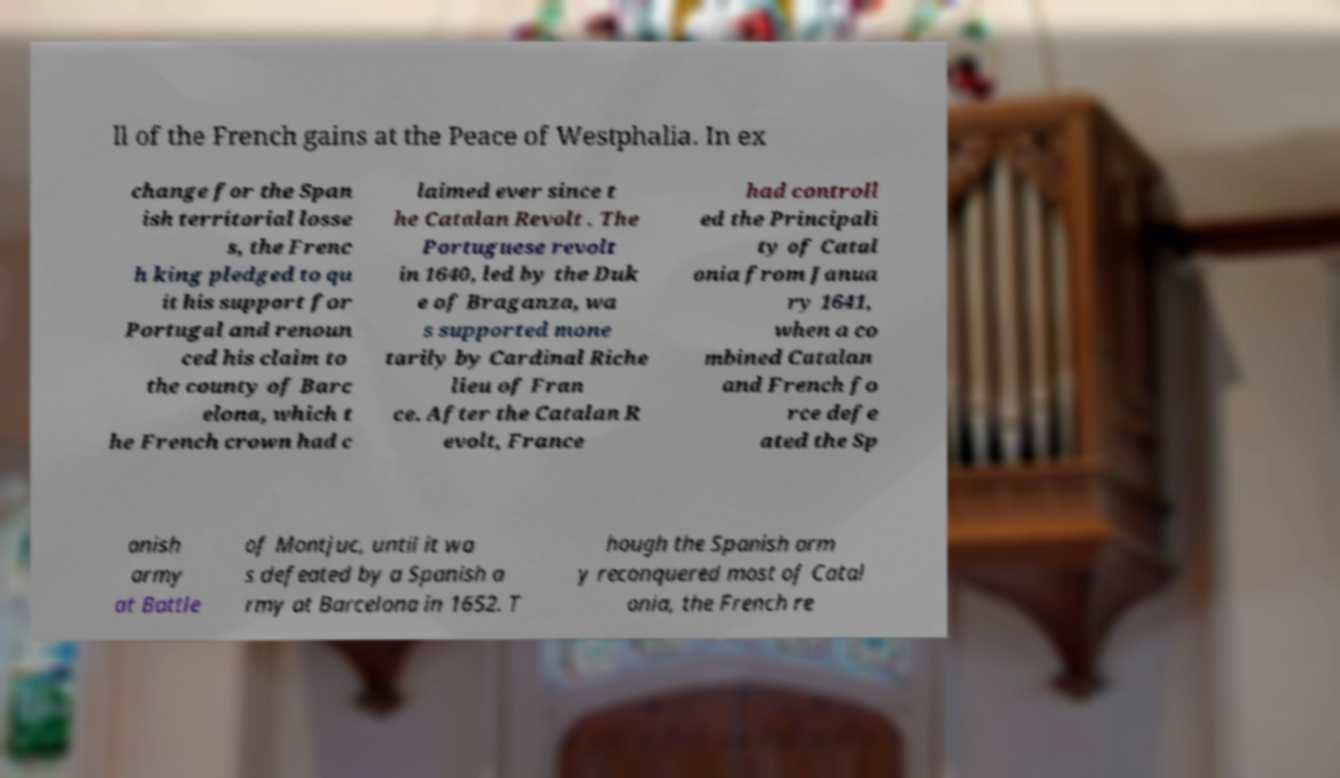What messages or text are displayed in this image? I need them in a readable, typed format. ll of the French gains at the Peace of Westphalia. In ex change for the Span ish territorial losse s, the Frenc h king pledged to qu it his support for Portugal and renoun ced his claim to the county of Barc elona, which t he French crown had c laimed ever since t he Catalan Revolt . The Portuguese revolt in 1640, led by the Duk e of Braganza, wa s supported mone tarily by Cardinal Riche lieu of Fran ce. After the Catalan R evolt, France had controll ed the Principali ty of Catal onia from Janua ry 1641, when a co mbined Catalan and French fo rce defe ated the Sp anish army at Battle of Montjuc, until it wa s defeated by a Spanish a rmy at Barcelona in 1652. T hough the Spanish arm y reconquered most of Catal onia, the French re 